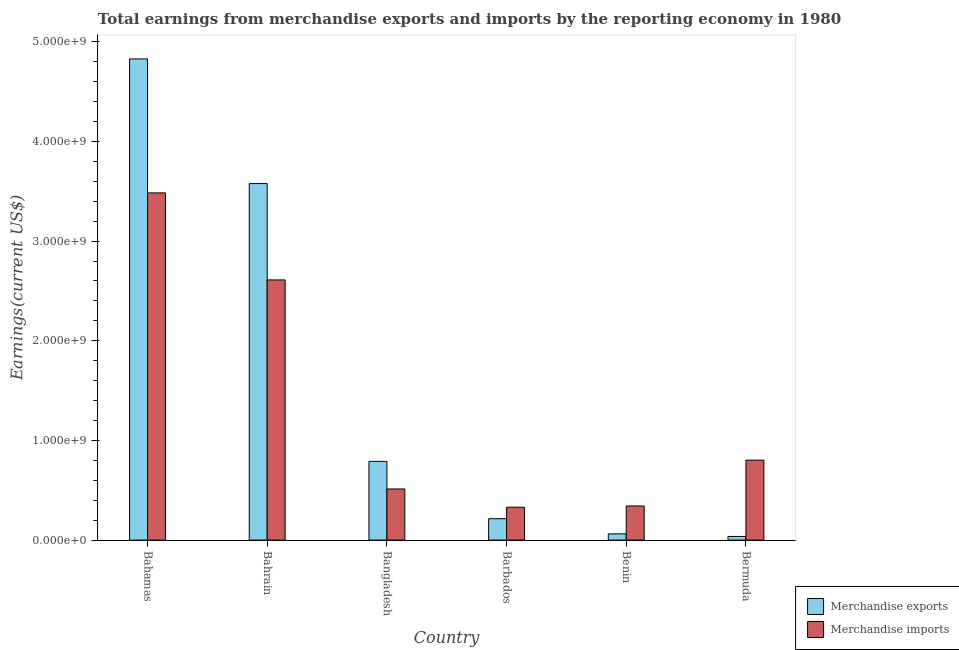How many groups of bars are there?
Keep it short and to the point. 6. Are the number of bars per tick equal to the number of legend labels?
Give a very brief answer. Yes. How many bars are there on the 1st tick from the right?
Provide a short and direct response. 2. What is the label of the 6th group of bars from the left?
Your response must be concise. Bermuda. What is the earnings from merchandise exports in Benin?
Your answer should be very brief. 6.28e+07. Across all countries, what is the maximum earnings from merchandise imports?
Offer a terse response. 3.48e+09. Across all countries, what is the minimum earnings from merchandise imports?
Offer a very short reply. 3.30e+08. In which country was the earnings from merchandise exports maximum?
Your response must be concise. Bahamas. In which country was the earnings from merchandise exports minimum?
Provide a short and direct response. Bermuda. What is the total earnings from merchandise exports in the graph?
Your answer should be very brief. 9.51e+09. What is the difference between the earnings from merchandise imports in Bahamas and that in Benin?
Your answer should be very brief. 3.14e+09. What is the difference between the earnings from merchandise exports in Bangladesh and the earnings from merchandise imports in Bahrain?
Give a very brief answer. -1.82e+09. What is the average earnings from merchandise exports per country?
Give a very brief answer. 1.58e+09. What is the difference between the earnings from merchandise imports and earnings from merchandise exports in Bahrain?
Provide a succinct answer. -9.67e+08. In how many countries, is the earnings from merchandise imports greater than 2600000000 US$?
Keep it short and to the point. 2. What is the ratio of the earnings from merchandise imports in Bahamas to that in Bangladesh?
Give a very brief answer. 6.79. Is the earnings from merchandise imports in Bahrain less than that in Bangladesh?
Your answer should be very brief. No. What is the difference between the highest and the second highest earnings from merchandise imports?
Make the answer very short. 8.73e+08. What is the difference between the highest and the lowest earnings from merchandise exports?
Your answer should be compact. 4.79e+09. What does the 2nd bar from the left in Benin represents?
Keep it short and to the point. Merchandise imports. What does the 1st bar from the right in Bahrain represents?
Keep it short and to the point. Merchandise imports. How many countries are there in the graph?
Offer a terse response. 6. Are the values on the major ticks of Y-axis written in scientific E-notation?
Offer a terse response. Yes. Does the graph contain grids?
Your answer should be very brief. No. How are the legend labels stacked?
Make the answer very short. Vertical. What is the title of the graph?
Offer a very short reply. Total earnings from merchandise exports and imports by the reporting economy in 1980. Does "Number of arrivals" appear as one of the legend labels in the graph?
Your answer should be very brief. No. What is the label or title of the Y-axis?
Keep it short and to the point. Earnings(current US$). What is the Earnings(current US$) of Merchandise exports in Bahamas?
Your answer should be compact. 4.83e+09. What is the Earnings(current US$) in Merchandise imports in Bahamas?
Offer a terse response. 3.48e+09. What is the Earnings(current US$) of Merchandise exports in Bahrain?
Keep it short and to the point. 3.58e+09. What is the Earnings(current US$) of Merchandise imports in Bahrain?
Provide a short and direct response. 2.61e+09. What is the Earnings(current US$) in Merchandise exports in Bangladesh?
Provide a short and direct response. 7.90e+08. What is the Earnings(current US$) in Merchandise imports in Bangladesh?
Provide a succinct answer. 5.13e+08. What is the Earnings(current US$) of Merchandise exports in Barbados?
Your answer should be very brief. 2.15e+08. What is the Earnings(current US$) of Merchandise imports in Barbados?
Give a very brief answer. 3.30e+08. What is the Earnings(current US$) in Merchandise exports in Benin?
Keep it short and to the point. 6.28e+07. What is the Earnings(current US$) of Merchandise imports in Benin?
Your response must be concise. 3.43e+08. What is the Earnings(current US$) of Merchandise exports in Bermuda?
Offer a very short reply. 3.65e+07. What is the Earnings(current US$) of Merchandise imports in Bermuda?
Provide a short and direct response. 8.02e+08. Across all countries, what is the maximum Earnings(current US$) of Merchandise exports?
Your answer should be compact. 4.83e+09. Across all countries, what is the maximum Earnings(current US$) of Merchandise imports?
Ensure brevity in your answer.  3.48e+09. Across all countries, what is the minimum Earnings(current US$) of Merchandise exports?
Your answer should be very brief. 3.65e+07. Across all countries, what is the minimum Earnings(current US$) of Merchandise imports?
Provide a short and direct response. 3.30e+08. What is the total Earnings(current US$) of Merchandise exports in the graph?
Ensure brevity in your answer.  9.51e+09. What is the total Earnings(current US$) of Merchandise imports in the graph?
Offer a terse response. 8.08e+09. What is the difference between the Earnings(current US$) of Merchandise exports in Bahamas and that in Bahrain?
Provide a succinct answer. 1.25e+09. What is the difference between the Earnings(current US$) in Merchandise imports in Bahamas and that in Bahrain?
Give a very brief answer. 8.73e+08. What is the difference between the Earnings(current US$) of Merchandise exports in Bahamas and that in Bangladesh?
Your answer should be very brief. 4.04e+09. What is the difference between the Earnings(current US$) in Merchandise imports in Bahamas and that in Bangladesh?
Your answer should be compact. 2.97e+09. What is the difference between the Earnings(current US$) of Merchandise exports in Bahamas and that in Barbados?
Your answer should be very brief. 4.61e+09. What is the difference between the Earnings(current US$) of Merchandise imports in Bahamas and that in Barbados?
Your response must be concise. 3.15e+09. What is the difference between the Earnings(current US$) of Merchandise exports in Bahamas and that in Benin?
Your response must be concise. 4.77e+09. What is the difference between the Earnings(current US$) of Merchandise imports in Bahamas and that in Benin?
Offer a very short reply. 3.14e+09. What is the difference between the Earnings(current US$) of Merchandise exports in Bahamas and that in Bermuda?
Offer a very short reply. 4.79e+09. What is the difference between the Earnings(current US$) of Merchandise imports in Bahamas and that in Bermuda?
Offer a very short reply. 2.68e+09. What is the difference between the Earnings(current US$) in Merchandise exports in Bahrain and that in Bangladesh?
Your answer should be compact. 2.79e+09. What is the difference between the Earnings(current US$) of Merchandise imports in Bahrain and that in Bangladesh?
Your response must be concise. 2.10e+09. What is the difference between the Earnings(current US$) in Merchandise exports in Bahrain and that in Barbados?
Keep it short and to the point. 3.36e+09. What is the difference between the Earnings(current US$) of Merchandise imports in Bahrain and that in Barbados?
Provide a succinct answer. 2.28e+09. What is the difference between the Earnings(current US$) in Merchandise exports in Bahrain and that in Benin?
Offer a terse response. 3.51e+09. What is the difference between the Earnings(current US$) in Merchandise imports in Bahrain and that in Benin?
Provide a succinct answer. 2.27e+09. What is the difference between the Earnings(current US$) of Merchandise exports in Bahrain and that in Bermuda?
Ensure brevity in your answer.  3.54e+09. What is the difference between the Earnings(current US$) of Merchandise imports in Bahrain and that in Bermuda?
Give a very brief answer. 1.81e+09. What is the difference between the Earnings(current US$) in Merchandise exports in Bangladesh and that in Barbados?
Your answer should be very brief. 5.75e+08. What is the difference between the Earnings(current US$) in Merchandise imports in Bangladesh and that in Barbados?
Your response must be concise. 1.83e+08. What is the difference between the Earnings(current US$) of Merchandise exports in Bangladesh and that in Benin?
Make the answer very short. 7.27e+08. What is the difference between the Earnings(current US$) in Merchandise imports in Bangladesh and that in Benin?
Make the answer very short. 1.70e+08. What is the difference between the Earnings(current US$) in Merchandise exports in Bangladesh and that in Bermuda?
Your answer should be very brief. 7.54e+08. What is the difference between the Earnings(current US$) in Merchandise imports in Bangladesh and that in Bermuda?
Give a very brief answer. -2.89e+08. What is the difference between the Earnings(current US$) in Merchandise exports in Barbados and that in Benin?
Give a very brief answer. 1.52e+08. What is the difference between the Earnings(current US$) in Merchandise imports in Barbados and that in Benin?
Give a very brief answer. -1.27e+07. What is the difference between the Earnings(current US$) of Merchandise exports in Barbados and that in Bermuda?
Ensure brevity in your answer.  1.78e+08. What is the difference between the Earnings(current US$) of Merchandise imports in Barbados and that in Bermuda?
Ensure brevity in your answer.  -4.72e+08. What is the difference between the Earnings(current US$) of Merchandise exports in Benin and that in Bermuda?
Your answer should be very brief. 2.63e+07. What is the difference between the Earnings(current US$) in Merchandise imports in Benin and that in Bermuda?
Keep it short and to the point. -4.59e+08. What is the difference between the Earnings(current US$) in Merchandise exports in Bahamas and the Earnings(current US$) in Merchandise imports in Bahrain?
Offer a terse response. 2.22e+09. What is the difference between the Earnings(current US$) of Merchandise exports in Bahamas and the Earnings(current US$) of Merchandise imports in Bangladesh?
Keep it short and to the point. 4.31e+09. What is the difference between the Earnings(current US$) of Merchandise exports in Bahamas and the Earnings(current US$) of Merchandise imports in Barbados?
Provide a short and direct response. 4.50e+09. What is the difference between the Earnings(current US$) in Merchandise exports in Bahamas and the Earnings(current US$) in Merchandise imports in Benin?
Offer a terse response. 4.49e+09. What is the difference between the Earnings(current US$) of Merchandise exports in Bahamas and the Earnings(current US$) of Merchandise imports in Bermuda?
Make the answer very short. 4.03e+09. What is the difference between the Earnings(current US$) of Merchandise exports in Bahrain and the Earnings(current US$) of Merchandise imports in Bangladesh?
Your answer should be compact. 3.06e+09. What is the difference between the Earnings(current US$) of Merchandise exports in Bahrain and the Earnings(current US$) of Merchandise imports in Barbados?
Make the answer very short. 3.25e+09. What is the difference between the Earnings(current US$) in Merchandise exports in Bahrain and the Earnings(current US$) in Merchandise imports in Benin?
Offer a very short reply. 3.23e+09. What is the difference between the Earnings(current US$) of Merchandise exports in Bahrain and the Earnings(current US$) of Merchandise imports in Bermuda?
Offer a terse response. 2.78e+09. What is the difference between the Earnings(current US$) of Merchandise exports in Bangladesh and the Earnings(current US$) of Merchandise imports in Barbados?
Your response must be concise. 4.60e+08. What is the difference between the Earnings(current US$) in Merchandise exports in Bangladesh and the Earnings(current US$) in Merchandise imports in Benin?
Offer a terse response. 4.48e+08. What is the difference between the Earnings(current US$) of Merchandise exports in Bangladesh and the Earnings(current US$) of Merchandise imports in Bermuda?
Your response must be concise. -1.19e+07. What is the difference between the Earnings(current US$) of Merchandise exports in Barbados and the Earnings(current US$) of Merchandise imports in Benin?
Offer a very short reply. -1.28e+08. What is the difference between the Earnings(current US$) in Merchandise exports in Barbados and the Earnings(current US$) in Merchandise imports in Bermuda?
Your answer should be compact. -5.87e+08. What is the difference between the Earnings(current US$) of Merchandise exports in Benin and the Earnings(current US$) of Merchandise imports in Bermuda?
Offer a terse response. -7.39e+08. What is the average Earnings(current US$) of Merchandise exports per country?
Provide a short and direct response. 1.58e+09. What is the average Earnings(current US$) in Merchandise imports per country?
Keep it short and to the point. 1.35e+09. What is the difference between the Earnings(current US$) of Merchandise exports and Earnings(current US$) of Merchandise imports in Bahamas?
Your response must be concise. 1.34e+09. What is the difference between the Earnings(current US$) of Merchandise exports and Earnings(current US$) of Merchandise imports in Bahrain?
Provide a short and direct response. 9.67e+08. What is the difference between the Earnings(current US$) of Merchandise exports and Earnings(current US$) of Merchandise imports in Bangladesh?
Ensure brevity in your answer.  2.77e+08. What is the difference between the Earnings(current US$) of Merchandise exports and Earnings(current US$) of Merchandise imports in Barbados?
Keep it short and to the point. -1.15e+08. What is the difference between the Earnings(current US$) in Merchandise exports and Earnings(current US$) in Merchandise imports in Benin?
Ensure brevity in your answer.  -2.80e+08. What is the difference between the Earnings(current US$) in Merchandise exports and Earnings(current US$) in Merchandise imports in Bermuda?
Your response must be concise. -7.66e+08. What is the ratio of the Earnings(current US$) of Merchandise exports in Bahamas to that in Bahrain?
Your response must be concise. 1.35. What is the ratio of the Earnings(current US$) in Merchandise imports in Bahamas to that in Bahrain?
Give a very brief answer. 1.33. What is the ratio of the Earnings(current US$) in Merchandise exports in Bahamas to that in Bangladesh?
Provide a short and direct response. 6.11. What is the ratio of the Earnings(current US$) of Merchandise imports in Bahamas to that in Bangladesh?
Your answer should be compact. 6.79. What is the ratio of the Earnings(current US$) in Merchandise exports in Bahamas to that in Barbados?
Your answer should be very brief. 22.49. What is the ratio of the Earnings(current US$) of Merchandise imports in Bahamas to that in Barbados?
Your response must be concise. 10.56. What is the ratio of the Earnings(current US$) of Merchandise exports in Bahamas to that in Benin?
Give a very brief answer. 76.87. What is the ratio of the Earnings(current US$) of Merchandise imports in Bahamas to that in Benin?
Your response must be concise. 10.17. What is the ratio of the Earnings(current US$) in Merchandise exports in Bahamas to that in Bermuda?
Your answer should be compact. 132.32. What is the ratio of the Earnings(current US$) of Merchandise imports in Bahamas to that in Bermuda?
Make the answer very short. 4.34. What is the ratio of the Earnings(current US$) of Merchandise exports in Bahrain to that in Bangladesh?
Provide a succinct answer. 4.53. What is the ratio of the Earnings(current US$) in Merchandise imports in Bahrain to that in Bangladesh?
Provide a short and direct response. 5.09. What is the ratio of the Earnings(current US$) in Merchandise exports in Bahrain to that in Barbados?
Offer a very short reply. 16.66. What is the ratio of the Earnings(current US$) in Merchandise imports in Bahrain to that in Barbados?
Offer a terse response. 7.91. What is the ratio of the Earnings(current US$) in Merchandise exports in Bahrain to that in Benin?
Offer a terse response. 56.95. What is the ratio of the Earnings(current US$) in Merchandise imports in Bahrain to that in Benin?
Provide a succinct answer. 7.62. What is the ratio of the Earnings(current US$) in Merchandise exports in Bahrain to that in Bermuda?
Give a very brief answer. 98.04. What is the ratio of the Earnings(current US$) in Merchandise imports in Bahrain to that in Bermuda?
Make the answer very short. 3.25. What is the ratio of the Earnings(current US$) in Merchandise exports in Bangladesh to that in Barbados?
Offer a terse response. 3.68. What is the ratio of the Earnings(current US$) of Merchandise imports in Bangladesh to that in Barbados?
Make the answer very short. 1.56. What is the ratio of the Earnings(current US$) in Merchandise exports in Bangladesh to that in Benin?
Keep it short and to the point. 12.58. What is the ratio of the Earnings(current US$) of Merchandise imports in Bangladesh to that in Benin?
Your answer should be very brief. 1.5. What is the ratio of the Earnings(current US$) of Merchandise exports in Bangladesh to that in Bermuda?
Provide a short and direct response. 21.66. What is the ratio of the Earnings(current US$) in Merchandise imports in Bangladesh to that in Bermuda?
Your response must be concise. 0.64. What is the ratio of the Earnings(current US$) of Merchandise exports in Barbados to that in Benin?
Your response must be concise. 3.42. What is the ratio of the Earnings(current US$) in Merchandise imports in Barbados to that in Benin?
Provide a succinct answer. 0.96. What is the ratio of the Earnings(current US$) in Merchandise exports in Barbados to that in Bermuda?
Make the answer very short. 5.88. What is the ratio of the Earnings(current US$) of Merchandise imports in Barbados to that in Bermuda?
Provide a short and direct response. 0.41. What is the ratio of the Earnings(current US$) in Merchandise exports in Benin to that in Bermuda?
Offer a very short reply. 1.72. What is the ratio of the Earnings(current US$) of Merchandise imports in Benin to that in Bermuda?
Keep it short and to the point. 0.43. What is the difference between the highest and the second highest Earnings(current US$) in Merchandise exports?
Provide a short and direct response. 1.25e+09. What is the difference between the highest and the second highest Earnings(current US$) in Merchandise imports?
Provide a succinct answer. 8.73e+08. What is the difference between the highest and the lowest Earnings(current US$) of Merchandise exports?
Give a very brief answer. 4.79e+09. What is the difference between the highest and the lowest Earnings(current US$) in Merchandise imports?
Offer a very short reply. 3.15e+09. 